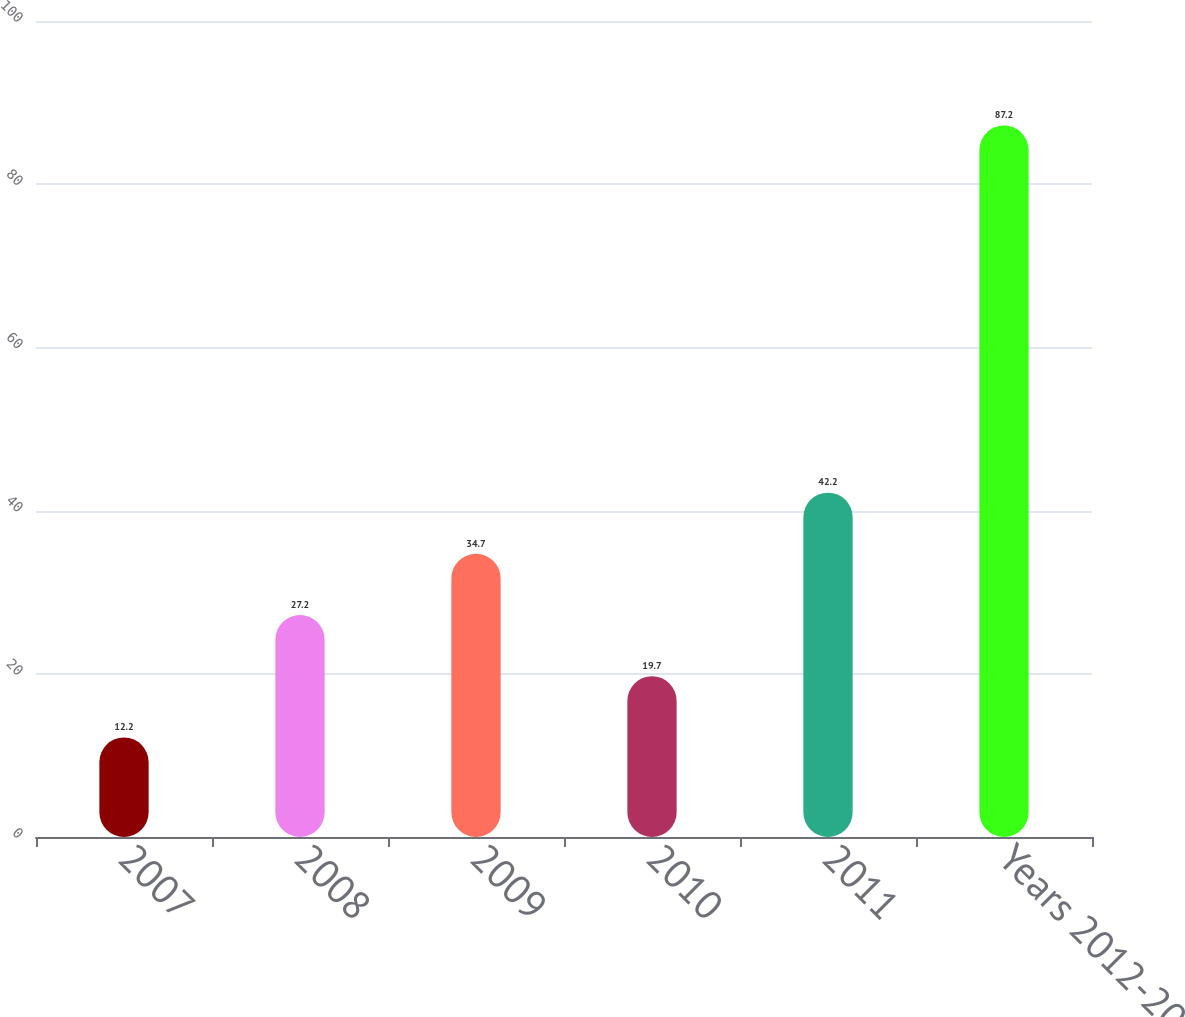Convert chart to OTSL. <chart><loc_0><loc_0><loc_500><loc_500><bar_chart><fcel>2007<fcel>2008<fcel>2009<fcel>2010<fcel>2011<fcel>Years 2012-2016<nl><fcel>12.2<fcel>27.2<fcel>34.7<fcel>19.7<fcel>42.2<fcel>87.2<nl></chart> 